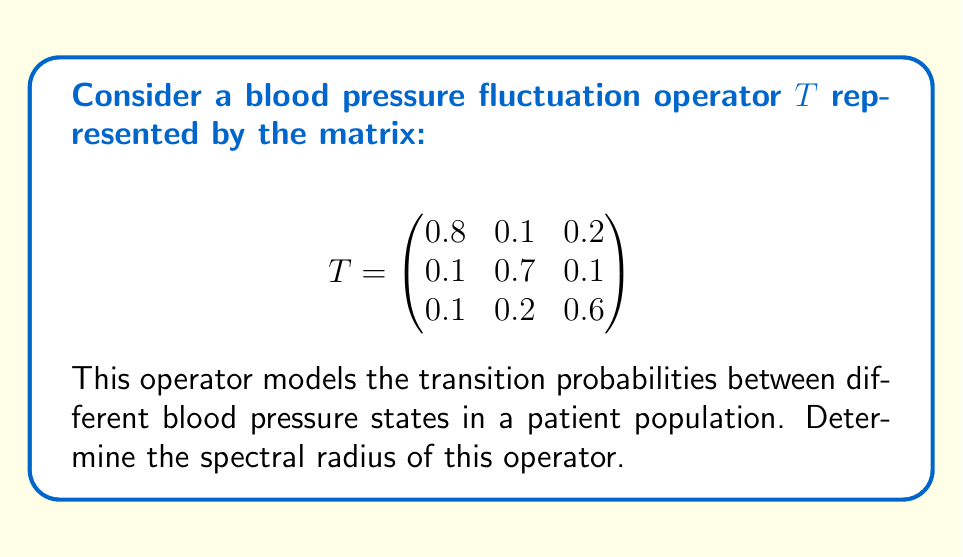Solve this math problem. To find the spectral radius of the operator $T$, we need to follow these steps:

1) The spectral radius is defined as the maximum absolute value of the eigenvalues of $T$.

2) To find the eigenvalues, we need to solve the characteristic equation:
   $$\det(T - \lambda I) = 0$$

3) Expanding this determinant:
   $$\begin{vmatrix}
   0.8-\lambda & 0.1 & 0.2 \\
   0.1 & 0.7-\lambda & 0.1 \\
   0.1 & 0.2 & 0.6-\lambda
   \end{vmatrix} = 0$$

4) This yields the characteristic polynomial:
   $$-\lambda^3 + 2.1\lambda^2 - 1.37\lambda + 0.278 = 0$$

5) Using the cubic formula or numerical methods, we can solve this equation to find the eigenvalues:
   $$\lambda_1 \approx 0.9703$$
   $$\lambda_2 \approx 0.6148$$
   $$\lambda_3 \approx 0.5149$$

6) The spectral radius is the maximum absolute value among these eigenvalues:
   $$\rho(T) = \max\{|\lambda_1|, |\lambda_2|, |\lambda_3|\} = |\lambda_1| \approx 0.9703$$

Therefore, the spectral radius of the blood pressure fluctuation operator $T$ is approximately 0.9703.
Answer: $\rho(T) \approx 0.9703$ 